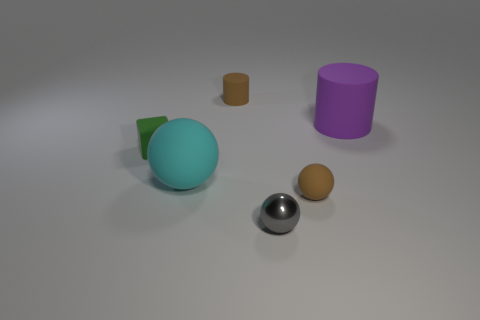What material is the object that is behind the cube and on the right side of the gray metal thing?
Make the answer very short. Rubber. How many things are rubber things right of the small cylinder or green rubber cubes?
Keep it short and to the point. 3. Is the small block the same color as the big cylinder?
Offer a very short reply. No. Is there a cyan rubber ball that has the same size as the green matte thing?
Offer a terse response. No. How many large rubber objects are behind the cyan rubber sphere and to the left of the small gray thing?
Your answer should be very brief. 0. There is a brown cylinder; what number of cylinders are in front of it?
Provide a short and direct response. 1. Are there any purple matte objects that have the same shape as the large cyan thing?
Give a very brief answer. No. Is the shape of the small metallic thing the same as the tiny rubber thing in front of the green rubber cube?
Your answer should be compact. Yes. How many cylinders are cyan matte things or small green rubber things?
Offer a very short reply. 0. What is the shape of the big thing that is on the right side of the tiny cylinder?
Provide a short and direct response. Cylinder. 